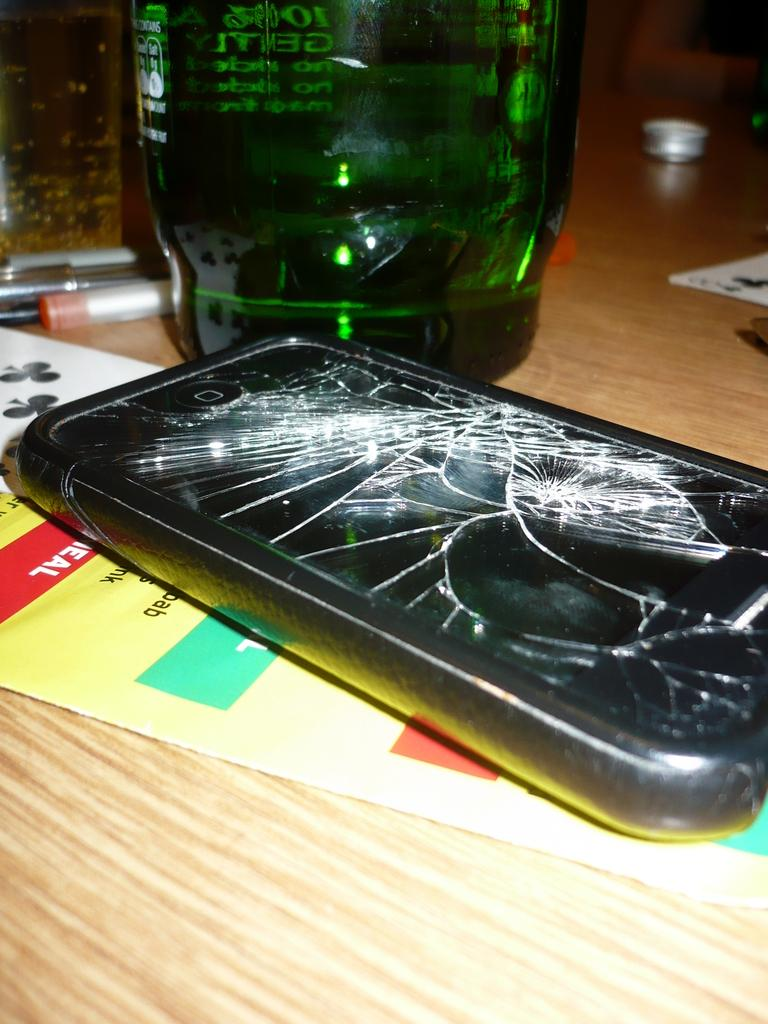What electronic device is present in the image? There is a mobile phone in the image. What is the condition of the mobile phone's glass? The glass of the mobile phone is broken. Where is the mobile phone located? The mobile phone is on a table. What type of bottle is present in the image? There is a green color glass bottle in the image. How is the green color glass bottle positioned in relation to the mobile phone? The green color glass bottle is beside the mobile phone. What type of fiction book is placed on the boundary in the image? There is no fiction book or boundary present in the image. 